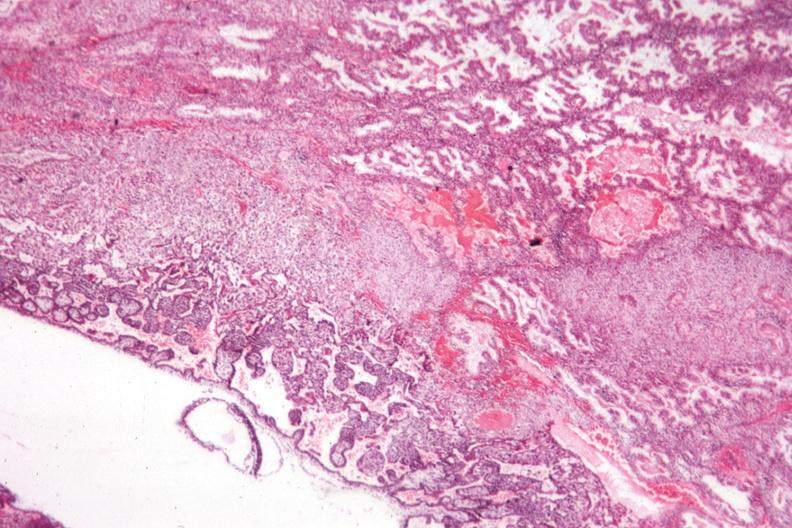s adenocarcinoma present?
Answer the question using a single word or phrase. No 